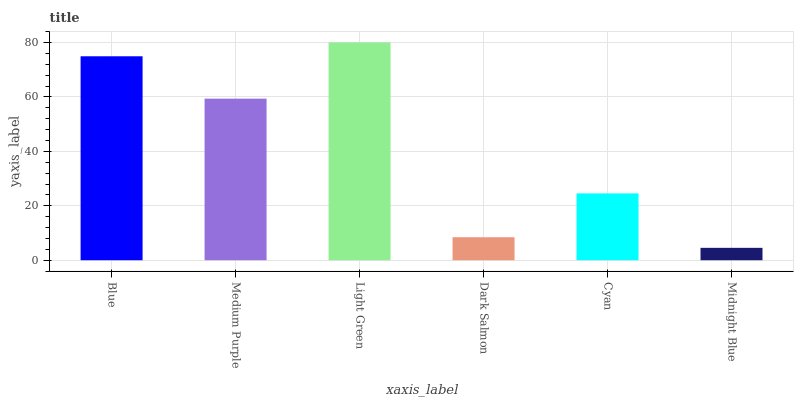Is Midnight Blue the minimum?
Answer yes or no. Yes. Is Light Green the maximum?
Answer yes or no. Yes. Is Medium Purple the minimum?
Answer yes or no. No. Is Medium Purple the maximum?
Answer yes or no. No. Is Blue greater than Medium Purple?
Answer yes or no. Yes. Is Medium Purple less than Blue?
Answer yes or no. Yes. Is Medium Purple greater than Blue?
Answer yes or no. No. Is Blue less than Medium Purple?
Answer yes or no. No. Is Medium Purple the high median?
Answer yes or no. Yes. Is Cyan the low median?
Answer yes or no. Yes. Is Cyan the high median?
Answer yes or no. No. Is Light Green the low median?
Answer yes or no. No. 